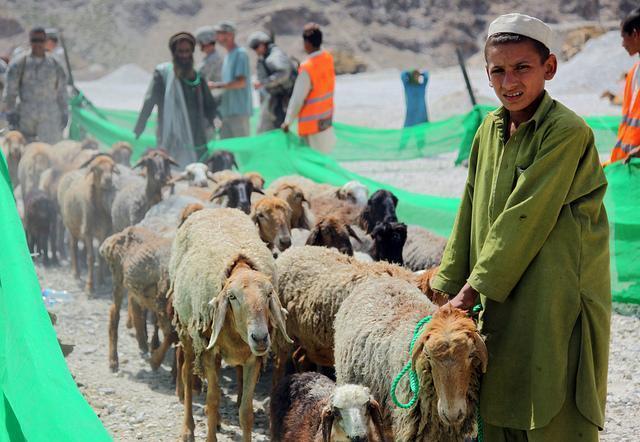Why are the men's vests orange in color?
From the following four choices, select the correct answer to address the question.
Options: Camouflage, dress code, fashion, visibility. Visibility. 